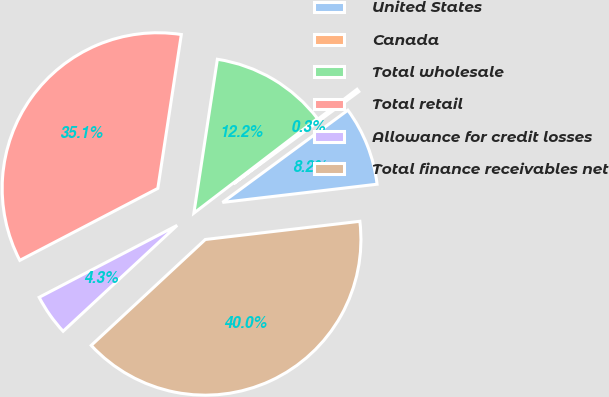<chart> <loc_0><loc_0><loc_500><loc_500><pie_chart><fcel>United States<fcel>Canada<fcel>Total wholesale<fcel>Total retail<fcel>Allowance for credit losses<fcel>Total finance receivables net<nl><fcel>8.23%<fcel>0.3%<fcel>12.19%<fcel>35.06%<fcel>4.26%<fcel>39.95%<nl></chart> 